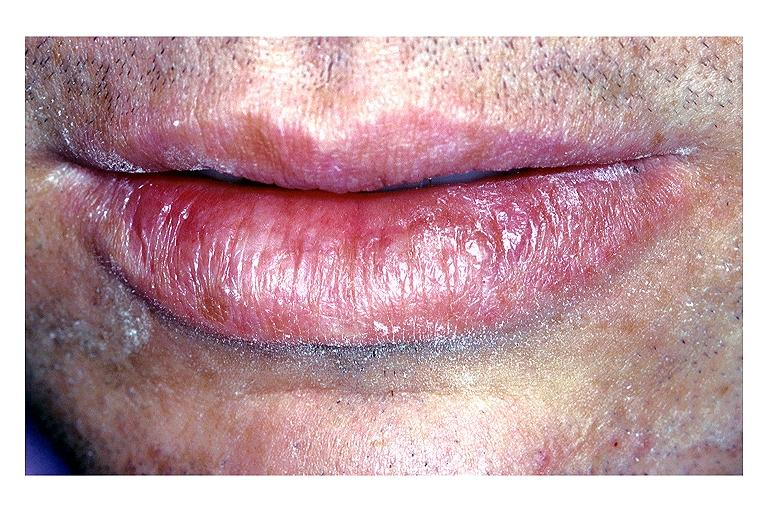what is present?
Answer the question using a single word or phrase. Oral 